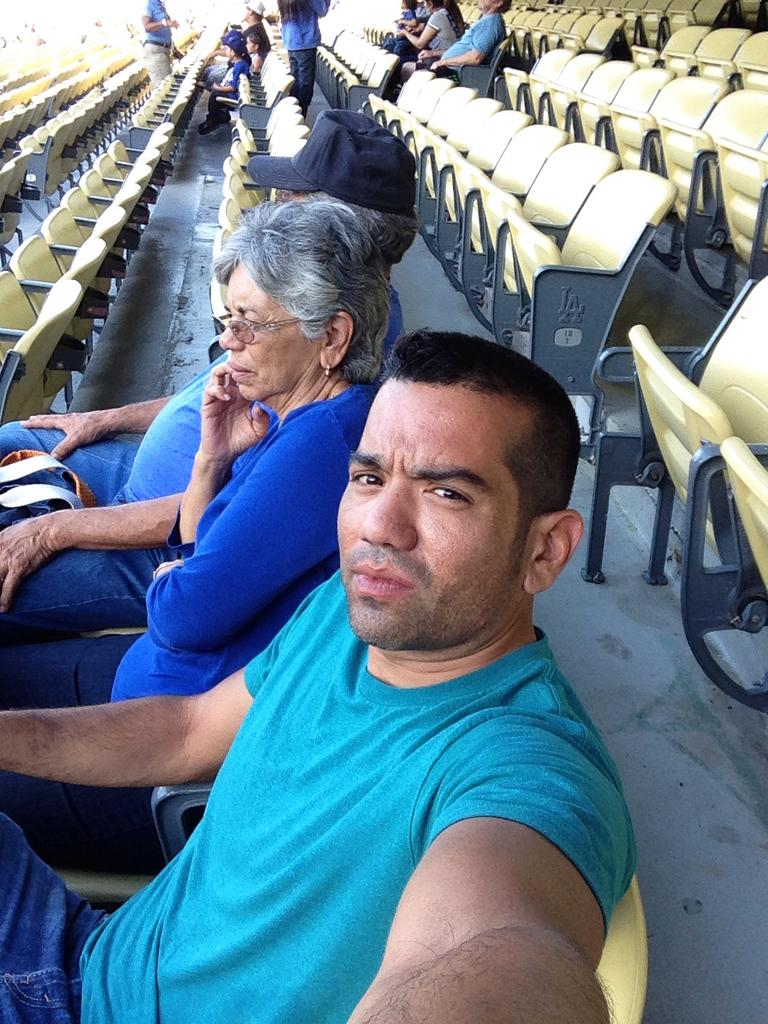What are the people in the center of the image doing? The people in the center of the image are sitting on chairs. Can you describe the people in the background of the image? There are people visible in the background of the image. Where are the chairs located on the right side of the image? The chairs on the right side of the image are visible. What purpose do the sticks serve in the image? There are no sticks present in the image. Can you see a giraffe in the image? There is no giraffe present in the image. 